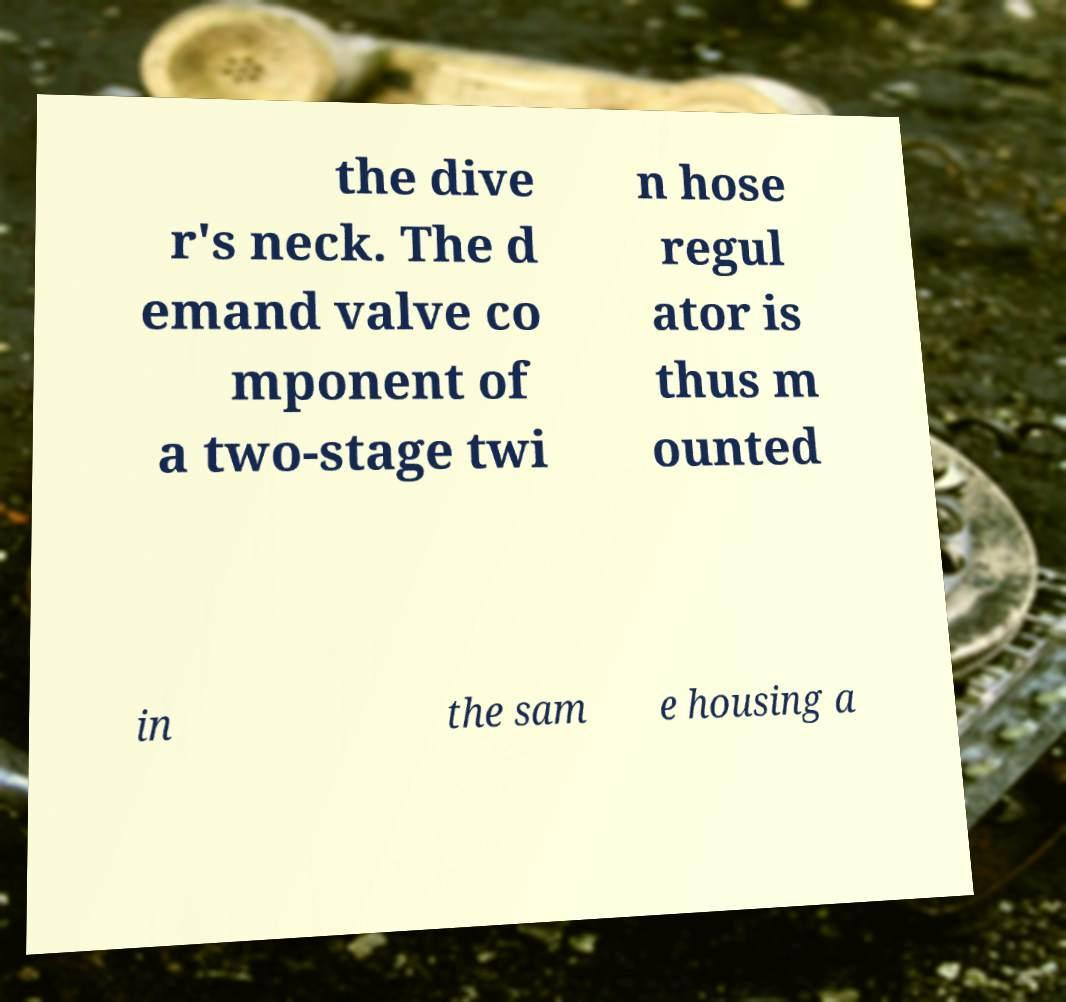I need the written content from this picture converted into text. Can you do that? the dive r's neck. The d emand valve co mponent of a two-stage twi n hose regul ator is thus m ounted in the sam e housing a 